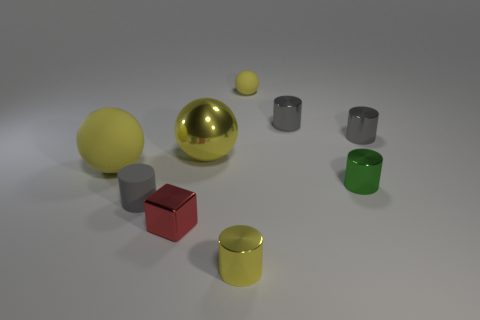There is a tiny yellow object in front of the matte sphere to the left of the small yellow cylinder in front of the red metal block; what shape is it?
Offer a very short reply. Cylinder. The tiny matte thing left of the rubber object on the right side of the red object is what shape?
Offer a very short reply. Cylinder. Is there a small purple ball that has the same material as the small green cylinder?
Your response must be concise. No. The other shiny thing that is the same color as the large metallic thing is what size?
Give a very brief answer. Small. What number of cyan things are tiny blocks or balls?
Make the answer very short. 0. Are there any small cubes that have the same color as the rubber cylinder?
Offer a terse response. No. The yellow cylinder that is the same material as the block is what size?
Ensure brevity in your answer.  Small. How many cubes are tiny green metal objects or yellow rubber objects?
Offer a very short reply. 0. Are there more gray objects than yellow shiny balls?
Ensure brevity in your answer.  Yes. How many yellow metal balls have the same size as the block?
Keep it short and to the point. 0. 